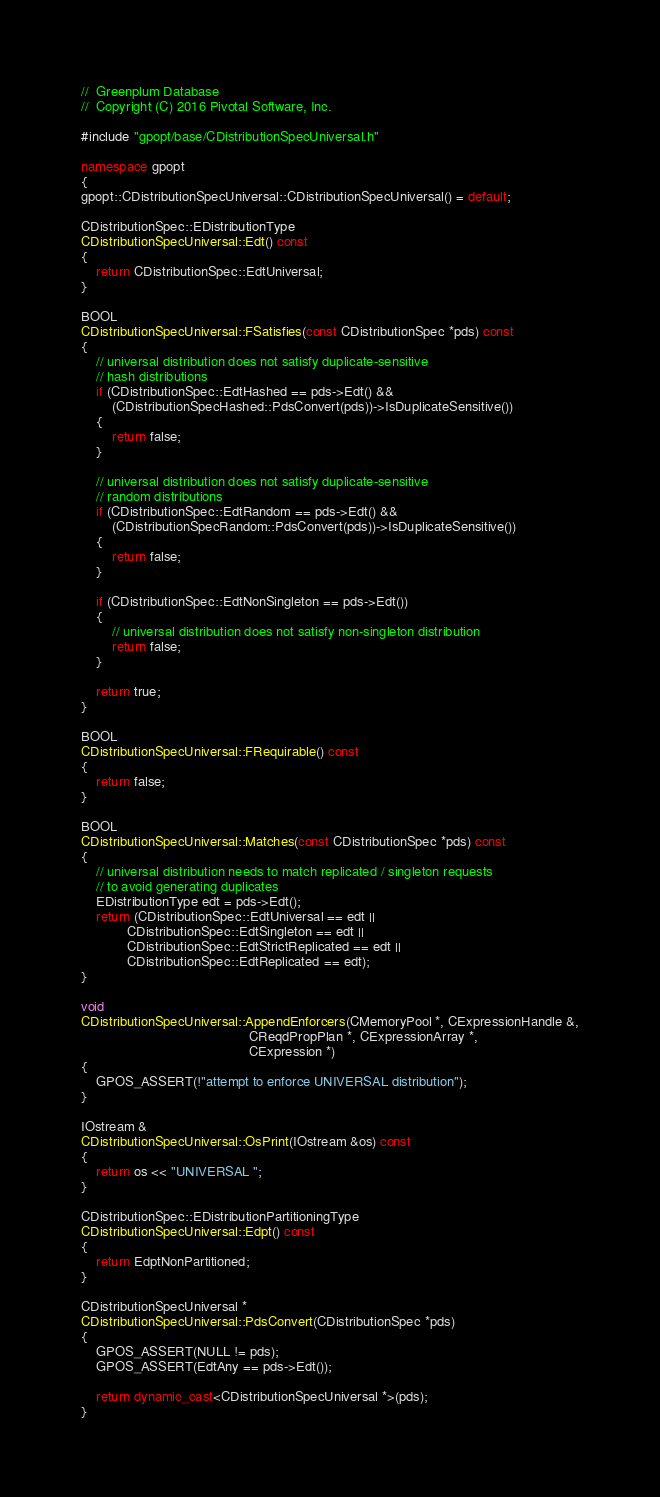<code> <loc_0><loc_0><loc_500><loc_500><_C++_>//	Greenplum Database
//	Copyright (C) 2016 Pivotal Software, Inc.

#include "gpopt/base/CDistributionSpecUniversal.h"

namespace gpopt
{
gpopt::CDistributionSpecUniversal::CDistributionSpecUniversal() = default;

CDistributionSpec::EDistributionType
CDistributionSpecUniversal::Edt() const
{
	return CDistributionSpec::EdtUniversal;
}

BOOL
CDistributionSpecUniversal::FSatisfies(const CDistributionSpec *pds) const
{
	// universal distribution does not satisfy duplicate-sensitive
	// hash distributions
	if (CDistributionSpec::EdtHashed == pds->Edt() &&
		(CDistributionSpecHashed::PdsConvert(pds))->IsDuplicateSensitive())
	{
		return false;
	}

	// universal distribution does not satisfy duplicate-sensitive
	// random distributions
	if (CDistributionSpec::EdtRandom == pds->Edt() &&
		(CDistributionSpecRandom::PdsConvert(pds))->IsDuplicateSensitive())
	{
		return false;
	}

	if (CDistributionSpec::EdtNonSingleton == pds->Edt())
	{
		// universal distribution does not satisfy non-singleton distribution
		return false;
	}

	return true;
}

BOOL
CDistributionSpecUniversal::FRequirable() const
{
	return false;
}

BOOL
CDistributionSpecUniversal::Matches(const CDistributionSpec *pds) const
{
	// universal distribution needs to match replicated / singleton requests
	// to avoid generating duplicates
	EDistributionType edt = pds->Edt();
	return (CDistributionSpec::EdtUniversal == edt ||
			CDistributionSpec::EdtSingleton == edt ||
			CDistributionSpec::EdtStrictReplicated == edt ||
			CDistributionSpec::EdtReplicated == edt);
}

void
CDistributionSpecUniversal::AppendEnforcers(CMemoryPool *, CExpressionHandle &,
											CReqdPropPlan *, CExpressionArray *,
											CExpression *)
{
	GPOS_ASSERT(!"attempt to enforce UNIVERSAL distribution");
}

IOstream &
CDistributionSpecUniversal::OsPrint(IOstream &os) const
{
	return os << "UNIVERSAL ";
}

CDistributionSpec::EDistributionPartitioningType
CDistributionSpecUniversal::Edpt() const
{
	return EdptNonPartitioned;
}

CDistributionSpecUniversal *
CDistributionSpecUniversal::PdsConvert(CDistributionSpec *pds)
{
	GPOS_ASSERT(NULL != pds);
	GPOS_ASSERT(EdtAny == pds->Edt());

	return dynamic_cast<CDistributionSpecUniversal *>(pds);
}</code> 